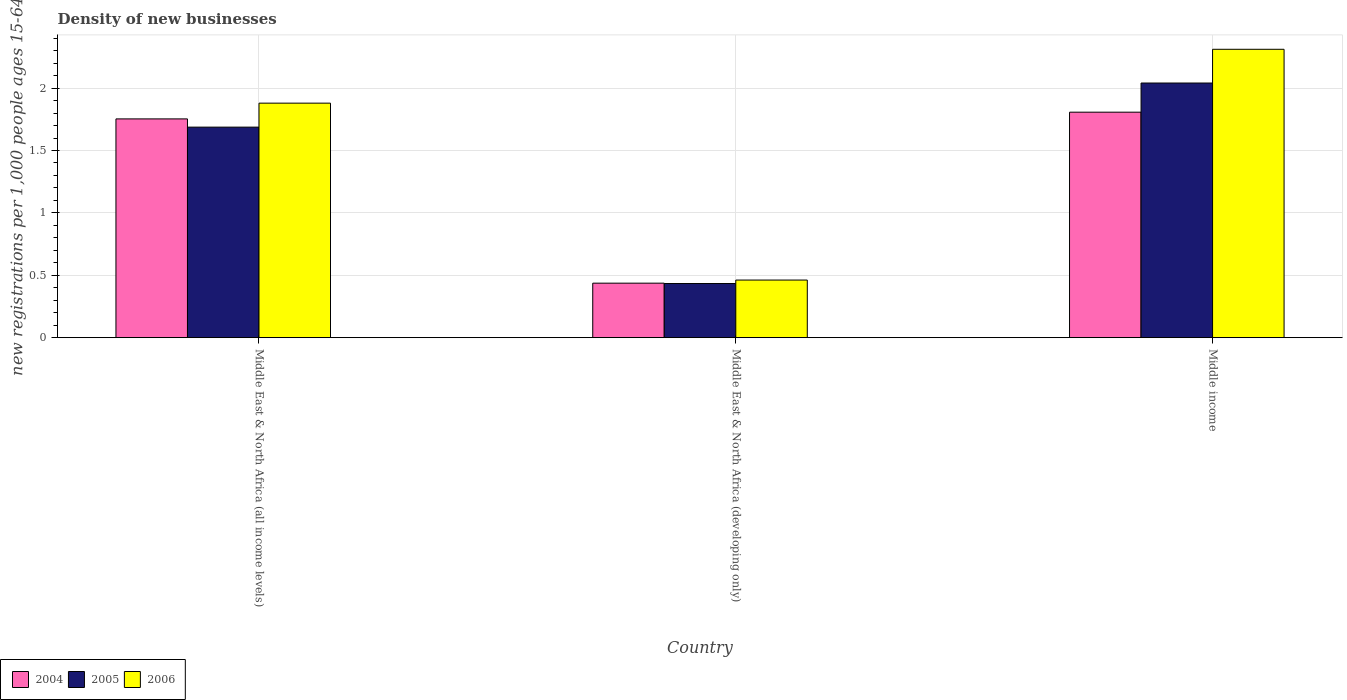Are the number of bars on each tick of the X-axis equal?
Provide a short and direct response. Yes. How many bars are there on the 2nd tick from the right?
Give a very brief answer. 3. What is the label of the 1st group of bars from the left?
Offer a terse response. Middle East & North Africa (all income levels). What is the number of new registrations in 2005 in Middle East & North Africa (developing only)?
Your response must be concise. 0.43. Across all countries, what is the maximum number of new registrations in 2006?
Your answer should be compact. 2.31. Across all countries, what is the minimum number of new registrations in 2006?
Your response must be concise. 0.46. In which country was the number of new registrations in 2006 maximum?
Give a very brief answer. Middle income. In which country was the number of new registrations in 2004 minimum?
Your answer should be very brief. Middle East & North Africa (developing only). What is the total number of new registrations in 2004 in the graph?
Keep it short and to the point. 4. What is the difference between the number of new registrations in 2005 in Middle East & North Africa (developing only) and that in Middle income?
Offer a terse response. -1.61. What is the difference between the number of new registrations in 2004 in Middle East & North Africa (all income levels) and the number of new registrations in 2005 in Middle East & North Africa (developing only)?
Your answer should be compact. 1.32. What is the average number of new registrations in 2006 per country?
Keep it short and to the point. 1.55. What is the difference between the number of new registrations of/in 2004 and number of new registrations of/in 2005 in Middle East & North Africa (all income levels)?
Keep it short and to the point. 0.07. What is the ratio of the number of new registrations in 2004 in Middle East & North Africa (all income levels) to that in Middle East & North Africa (developing only)?
Keep it short and to the point. 4.01. Is the number of new registrations in 2006 in Middle East & North Africa (developing only) less than that in Middle income?
Give a very brief answer. Yes. Is the difference between the number of new registrations in 2004 in Middle East & North Africa (all income levels) and Middle income greater than the difference between the number of new registrations in 2005 in Middle East & North Africa (all income levels) and Middle income?
Your answer should be very brief. Yes. What is the difference between the highest and the second highest number of new registrations in 2004?
Keep it short and to the point. -1.37. What is the difference between the highest and the lowest number of new registrations in 2006?
Ensure brevity in your answer.  1.85. In how many countries, is the number of new registrations in 2005 greater than the average number of new registrations in 2005 taken over all countries?
Your response must be concise. 2. What does the 1st bar from the right in Middle income represents?
Your answer should be compact. 2006. Is it the case that in every country, the sum of the number of new registrations in 2006 and number of new registrations in 2004 is greater than the number of new registrations in 2005?
Ensure brevity in your answer.  Yes. Are all the bars in the graph horizontal?
Provide a succinct answer. No. What is the difference between two consecutive major ticks on the Y-axis?
Your answer should be compact. 0.5. Are the values on the major ticks of Y-axis written in scientific E-notation?
Provide a succinct answer. No. Does the graph contain grids?
Ensure brevity in your answer.  Yes. Where does the legend appear in the graph?
Your answer should be compact. Bottom left. What is the title of the graph?
Give a very brief answer. Density of new businesses. What is the label or title of the X-axis?
Keep it short and to the point. Country. What is the label or title of the Y-axis?
Provide a short and direct response. New registrations per 1,0 people ages 15-64. What is the new registrations per 1,000 people ages 15-64 in 2004 in Middle East & North Africa (all income levels)?
Your answer should be very brief. 1.75. What is the new registrations per 1,000 people ages 15-64 in 2005 in Middle East & North Africa (all income levels)?
Give a very brief answer. 1.69. What is the new registrations per 1,000 people ages 15-64 in 2006 in Middle East & North Africa (all income levels)?
Keep it short and to the point. 1.88. What is the new registrations per 1,000 people ages 15-64 in 2004 in Middle East & North Africa (developing only)?
Ensure brevity in your answer.  0.44. What is the new registrations per 1,000 people ages 15-64 in 2005 in Middle East & North Africa (developing only)?
Make the answer very short. 0.43. What is the new registrations per 1,000 people ages 15-64 in 2006 in Middle East & North Africa (developing only)?
Keep it short and to the point. 0.46. What is the new registrations per 1,000 people ages 15-64 in 2004 in Middle income?
Your answer should be compact. 1.81. What is the new registrations per 1,000 people ages 15-64 in 2005 in Middle income?
Provide a short and direct response. 2.04. What is the new registrations per 1,000 people ages 15-64 in 2006 in Middle income?
Offer a very short reply. 2.31. Across all countries, what is the maximum new registrations per 1,000 people ages 15-64 in 2004?
Ensure brevity in your answer.  1.81. Across all countries, what is the maximum new registrations per 1,000 people ages 15-64 in 2005?
Provide a succinct answer. 2.04. Across all countries, what is the maximum new registrations per 1,000 people ages 15-64 in 2006?
Make the answer very short. 2.31. Across all countries, what is the minimum new registrations per 1,000 people ages 15-64 of 2004?
Ensure brevity in your answer.  0.44. Across all countries, what is the minimum new registrations per 1,000 people ages 15-64 of 2005?
Offer a very short reply. 0.43. Across all countries, what is the minimum new registrations per 1,000 people ages 15-64 of 2006?
Offer a very short reply. 0.46. What is the total new registrations per 1,000 people ages 15-64 of 2004 in the graph?
Keep it short and to the point. 4. What is the total new registrations per 1,000 people ages 15-64 in 2005 in the graph?
Make the answer very short. 4.16. What is the total new registrations per 1,000 people ages 15-64 of 2006 in the graph?
Offer a terse response. 4.65. What is the difference between the new registrations per 1,000 people ages 15-64 of 2004 in Middle East & North Africa (all income levels) and that in Middle East & North Africa (developing only)?
Your response must be concise. 1.32. What is the difference between the new registrations per 1,000 people ages 15-64 in 2005 in Middle East & North Africa (all income levels) and that in Middle East & North Africa (developing only)?
Give a very brief answer. 1.25. What is the difference between the new registrations per 1,000 people ages 15-64 in 2006 in Middle East & North Africa (all income levels) and that in Middle East & North Africa (developing only)?
Make the answer very short. 1.42. What is the difference between the new registrations per 1,000 people ages 15-64 of 2004 in Middle East & North Africa (all income levels) and that in Middle income?
Your answer should be very brief. -0.05. What is the difference between the new registrations per 1,000 people ages 15-64 in 2005 in Middle East & North Africa (all income levels) and that in Middle income?
Your answer should be compact. -0.35. What is the difference between the new registrations per 1,000 people ages 15-64 of 2006 in Middle East & North Africa (all income levels) and that in Middle income?
Your response must be concise. -0.43. What is the difference between the new registrations per 1,000 people ages 15-64 in 2004 in Middle East & North Africa (developing only) and that in Middle income?
Make the answer very short. -1.37. What is the difference between the new registrations per 1,000 people ages 15-64 in 2005 in Middle East & North Africa (developing only) and that in Middle income?
Your response must be concise. -1.61. What is the difference between the new registrations per 1,000 people ages 15-64 of 2006 in Middle East & North Africa (developing only) and that in Middle income?
Provide a short and direct response. -1.85. What is the difference between the new registrations per 1,000 people ages 15-64 of 2004 in Middle East & North Africa (all income levels) and the new registrations per 1,000 people ages 15-64 of 2005 in Middle East & North Africa (developing only)?
Offer a terse response. 1.32. What is the difference between the new registrations per 1,000 people ages 15-64 in 2004 in Middle East & North Africa (all income levels) and the new registrations per 1,000 people ages 15-64 in 2006 in Middle East & North Africa (developing only)?
Make the answer very short. 1.29. What is the difference between the new registrations per 1,000 people ages 15-64 in 2005 in Middle East & North Africa (all income levels) and the new registrations per 1,000 people ages 15-64 in 2006 in Middle East & North Africa (developing only)?
Your response must be concise. 1.23. What is the difference between the new registrations per 1,000 people ages 15-64 of 2004 in Middle East & North Africa (all income levels) and the new registrations per 1,000 people ages 15-64 of 2005 in Middle income?
Offer a terse response. -0.29. What is the difference between the new registrations per 1,000 people ages 15-64 of 2004 in Middle East & North Africa (all income levels) and the new registrations per 1,000 people ages 15-64 of 2006 in Middle income?
Offer a very short reply. -0.56. What is the difference between the new registrations per 1,000 people ages 15-64 in 2005 in Middle East & North Africa (all income levels) and the new registrations per 1,000 people ages 15-64 in 2006 in Middle income?
Offer a terse response. -0.62. What is the difference between the new registrations per 1,000 people ages 15-64 in 2004 in Middle East & North Africa (developing only) and the new registrations per 1,000 people ages 15-64 in 2005 in Middle income?
Make the answer very short. -1.6. What is the difference between the new registrations per 1,000 people ages 15-64 in 2004 in Middle East & North Africa (developing only) and the new registrations per 1,000 people ages 15-64 in 2006 in Middle income?
Ensure brevity in your answer.  -1.87. What is the difference between the new registrations per 1,000 people ages 15-64 of 2005 in Middle East & North Africa (developing only) and the new registrations per 1,000 people ages 15-64 of 2006 in Middle income?
Provide a succinct answer. -1.88. What is the average new registrations per 1,000 people ages 15-64 in 2004 per country?
Provide a short and direct response. 1.33. What is the average new registrations per 1,000 people ages 15-64 in 2005 per country?
Your answer should be very brief. 1.39. What is the average new registrations per 1,000 people ages 15-64 of 2006 per country?
Your response must be concise. 1.55. What is the difference between the new registrations per 1,000 people ages 15-64 in 2004 and new registrations per 1,000 people ages 15-64 in 2005 in Middle East & North Africa (all income levels)?
Offer a very short reply. 0.07. What is the difference between the new registrations per 1,000 people ages 15-64 of 2004 and new registrations per 1,000 people ages 15-64 of 2006 in Middle East & North Africa (all income levels)?
Keep it short and to the point. -0.13. What is the difference between the new registrations per 1,000 people ages 15-64 in 2005 and new registrations per 1,000 people ages 15-64 in 2006 in Middle East & North Africa (all income levels)?
Your answer should be very brief. -0.19. What is the difference between the new registrations per 1,000 people ages 15-64 in 2004 and new registrations per 1,000 people ages 15-64 in 2005 in Middle East & North Africa (developing only)?
Keep it short and to the point. 0. What is the difference between the new registrations per 1,000 people ages 15-64 of 2004 and new registrations per 1,000 people ages 15-64 of 2006 in Middle East & North Africa (developing only)?
Offer a terse response. -0.02. What is the difference between the new registrations per 1,000 people ages 15-64 of 2005 and new registrations per 1,000 people ages 15-64 of 2006 in Middle East & North Africa (developing only)?
Keep it short and to the point. -0.03. What is the difference between the new registrations per 1,000 people ages 15-64 of 2004 and new registrations per 1,000 people ages 15-64 of 2005 in Middle income?
Offer a terse response. -0.23. What is the difference between the new registrations per 1,000 people ages 15-64 in 2004 and new registrations per 1,000 people ages 15-64 in 2006 in Middle income?
Make the answer very short. -0.5. What is the difference between the new registrations per 1,000 people ages 15-64 of 2005 and new registrations per 1,000 people ages 15-64 of 2006 in Middle income?
Provide a short and direct response. -0.27. What is the ratio of the new registrations per 1,000 people ages 15-64 of 2004 in Middle East & North Africa (all income levels) to that in Middle East & North Africa (developing only)?
Ensure brevity in your answer.  4.01. What is the ratio of the new registrations per 1,000 people ages 15-64 in 2005 in Middle East & North Africa (all income levels) to that in Middle East & North Africa (developing only)?
Your answer should be very brief. 3.89. What is the ratio of the new registrations per 1,000 people ages 15-64 of 2006 in Middle East & North Africa (all income levels) to that in Middle East & North Africa (developing only)?
Give a very brief answer. 4.07. What is the ratio of the new registrations per 1,000 people ages 15-64 of 2004 in Middle East & North Africa (all income levels) to that in Middle income?
Give a very brief answer. 0.97. What is the ratio of the new registrations per 1,000 people ages 15-64 of 2005 in Middle East & North Africa (all income levels) to that in Middle income?
Ensure brevity in your answer.  0.83. What is the ratio of the new registrations per 1,000 people ages 15-64 of 2006 in Middle East & North Africa (all income levels) to that in Middle income?
Provide a short and direct response. 0.81. What is the ratio of the new registrations per 1,000 people ages 15-64 of 2004 in Middle East & North Africa (developing only) to that in Middle income?
Ensure brevity in your answer.  0.24. What is the ratio of the new registrations per 1,000 people ages 15-64 of 2005 in Middle East & North Africa (developing only) to that in Middle income?
Ensure brevity in your answer.  0.21. What is the ratio of the new registrations per 1,000 people ages 15-64 in 2006 in Middle East & North Africa (developing only) to that in Middle income?
Your response must be concise. 0.2. What is the difference between the highest and the second highest new registrations per 1,000 people ages 15-64 in 2004?
Provide a short and direct response. 0.05. What is the difference between the highest and the second highest new registrations per 1,000 people ages 15-64 of 2005?
Give a very brief answer. 0.35. What is the difference between the highest and the second highest new registrations per 1,000 people ages 15-64 in 2006?
Provide a succinct answer. 0.43. What is the difference between the highest and the lowest new registrations per 1,000 people ages 15-64 of 2004?
Give a very brief answer. 1.37. What is the difference between the highest and the lowest new registrations per 1,000 people ages 15-64 in 2005?
Your answer should be compact. 1.61. What is the difference between the highest and the lowest new registrations per 1,000 people ages 15-64 in 2006?
Your answer should be compact. 1.85. 